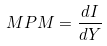Convert formula to latex. <formula><loc_0><loc_0><loc_500><loc_500>M P M = \frac { d I } { d Y }</formula> 